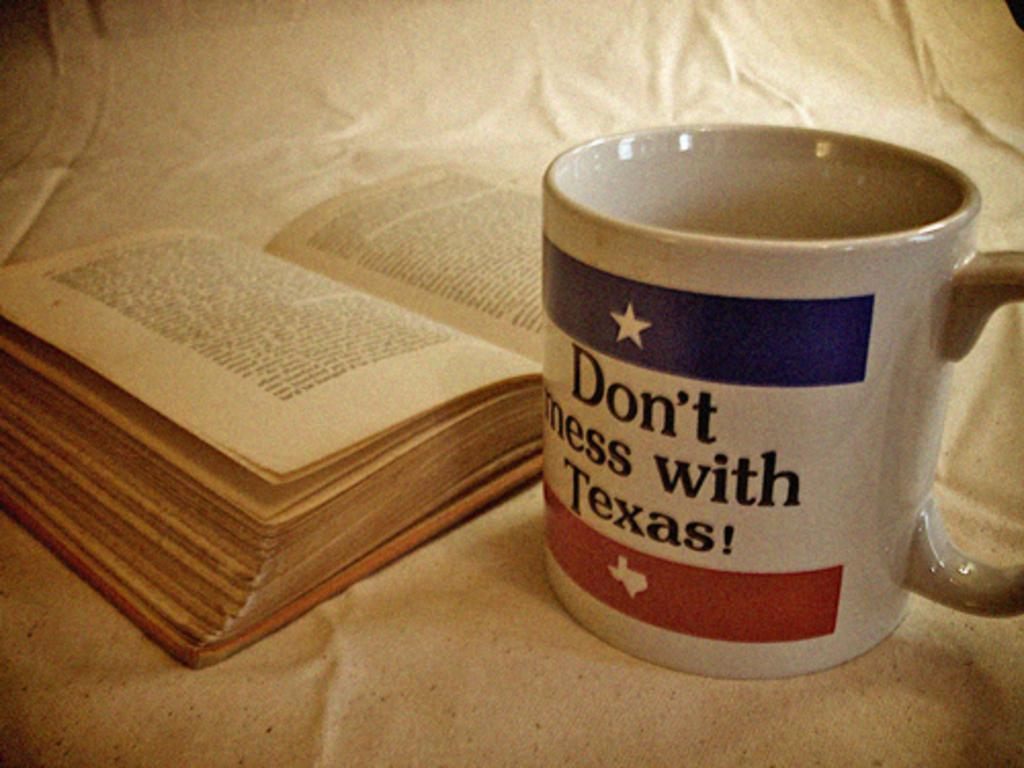<image>
Present a compact description of the photo's key features. A coffee mug warns people not to mess with Texas. 